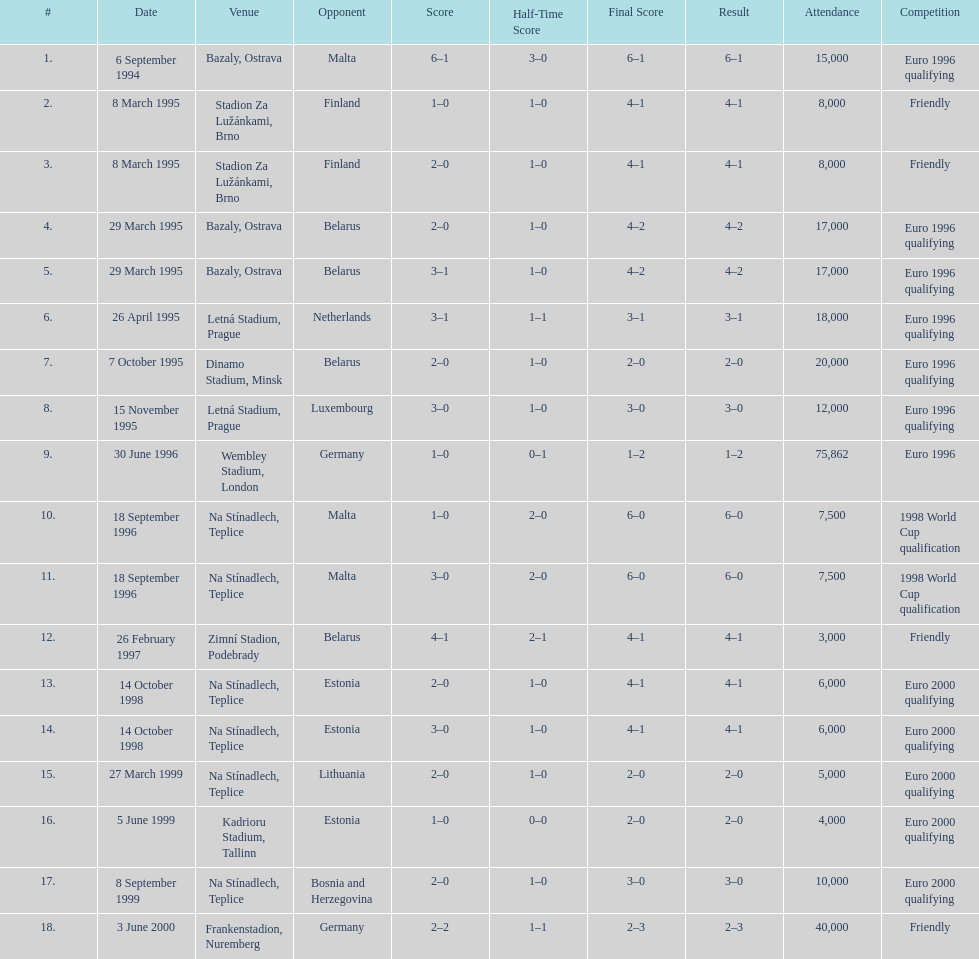List the opponent in which the result was the least out of all the results. Germany. 